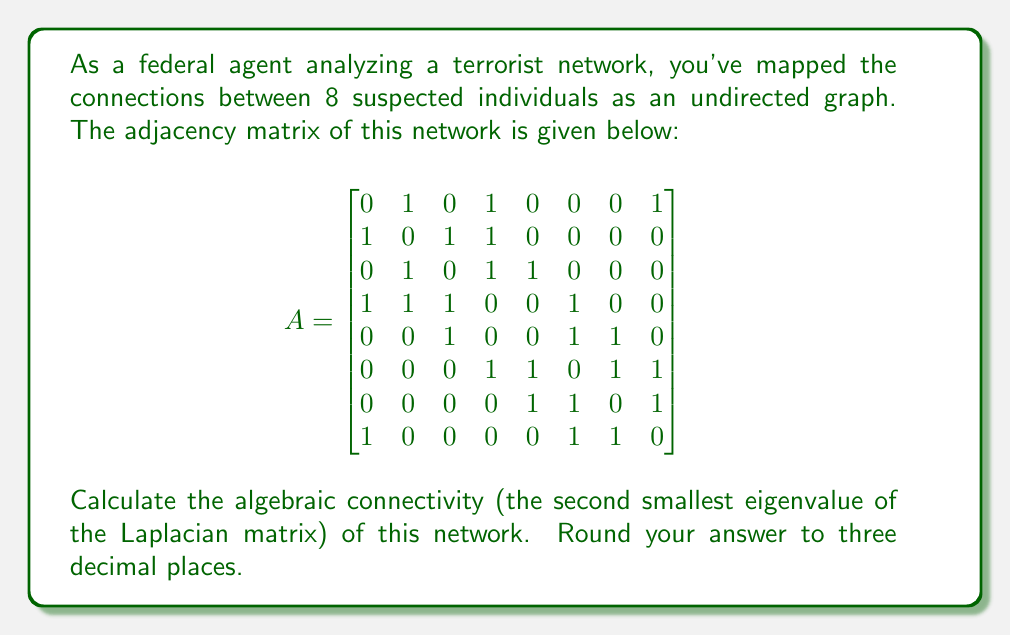Give your solution to this math problem. To solve this problem, we'll follow these steps:

1) First, we need to calculate the Laplacian matrix $L$ of the graph. The Laplacian matrix is defined as $L = D - A$, where $D$ is the degree matrix and $A$ is the adjacency matrix.

2) To find the degree matrix $D$, we sum each row of the adjacency matrix:

   $$D = \text{diag}(3, 3, 3, 4, 3, 4, 3, 3)$$

3) Now we can calculate the Laplacian matrix $L$:

   $$
   L = \begin{bmatrix}
   3 & -1 & 0 & -1 & 0 & 0 & 0 & -1 \\
   -1 & 3 & -1 & -1 & 0 & 0 & 0 & 0 \\
   0 & -1 & 3 & -1 & -1 & 0 & 0 & 0 \\
   -1 & -1 & -1 & 4 & 0 & -1 & 0 & 0 \\
   0 & 0 & -1 & 0 & 3 & -1 & -1 & 0 \\
   0 & 0 & 0 & -1 & -1 & 4 & -1 & -1 \\
   0 & 0 & 0 & 0 & -1 & -1 & 3 & -1 \\
   -1 & 0 & 0 & 0 & 0 & -1 & -1 & 3
   \end{bmatrix}
   $$

4) The algebraic connectivity is the second smallest eigenvalue of $L$. We need to find the eigenvalues of $L$.

5) Using a computer algebra system or numerical methods, we can calculate the eigenvalues of $L$:

   $$\lambda \approx 0, 0.830, 1.000, 2.000, 3.000, 4.000, 5.000, 6.170$$

6) The second smallest eigenvalue is approximately 0.830.

7) Rounding to three decimal places, we get 0.830.
Answer: 0.830 